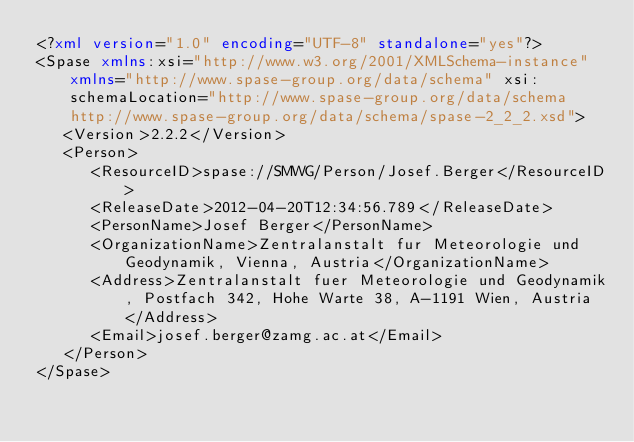<code> <loc_0><loc_0><loc_500><loc_500><_XML_><?xml version="1.0" encoding="UTF-8" standalone="yes"?>
<Spase xmlns:xsi="http://www.w3.org/2001/XMLSchema-instance" xmlns="http://www.spase-group.org/data/schema" xsi:schemaLocation="http://www.spase-group.org/data/schema http://www.spase-group.org/data/schema/spase-2_2_2.xsd">
   <Version>2.2.2</Version>
   <Person>
      <ResourceID>spase://SMWG/Person/Josef.Berger</ResourceID>
      <ReleaseDate>2012-04-20T12:34:56.789</ReleaseDate>
      <PersonName>Josef Berger</PersonName>
      <OrganizationName>Zentralanstalt fur Meteorologie und Geodynamik, Vienna, Austria</OrganizationName>
      <Address>Zentralanstalt fuer Meteorologie und Geodynamik, Postfach 342, Hohe Warte 38, A-1191 Wien, Austria</Address>
      <Email>josef.berger@zamg.ac.at</Email>
   </Person>
</Spase>
</code> 